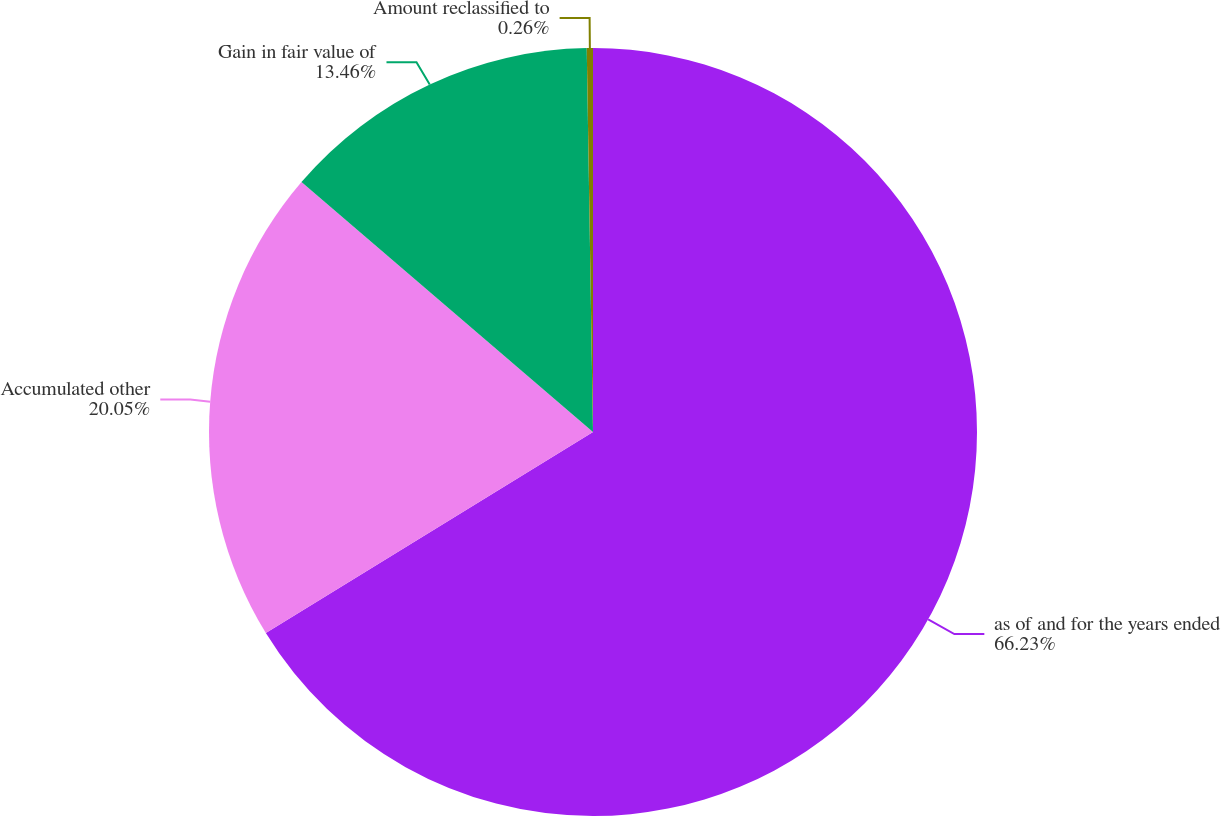Convert chart to OTSL. <chart><loc_0><loc_0><loc_500><loc_500><pie_chart><fcel>as of and for the years ended<fcel>Accumulated other<fcel>Gain in fair value of<fcel>Amount reclassified to<nl><fcel>66.23%<fcel>20.05%<fcel>13.46%<fcel>0.26%<nl></chart> 